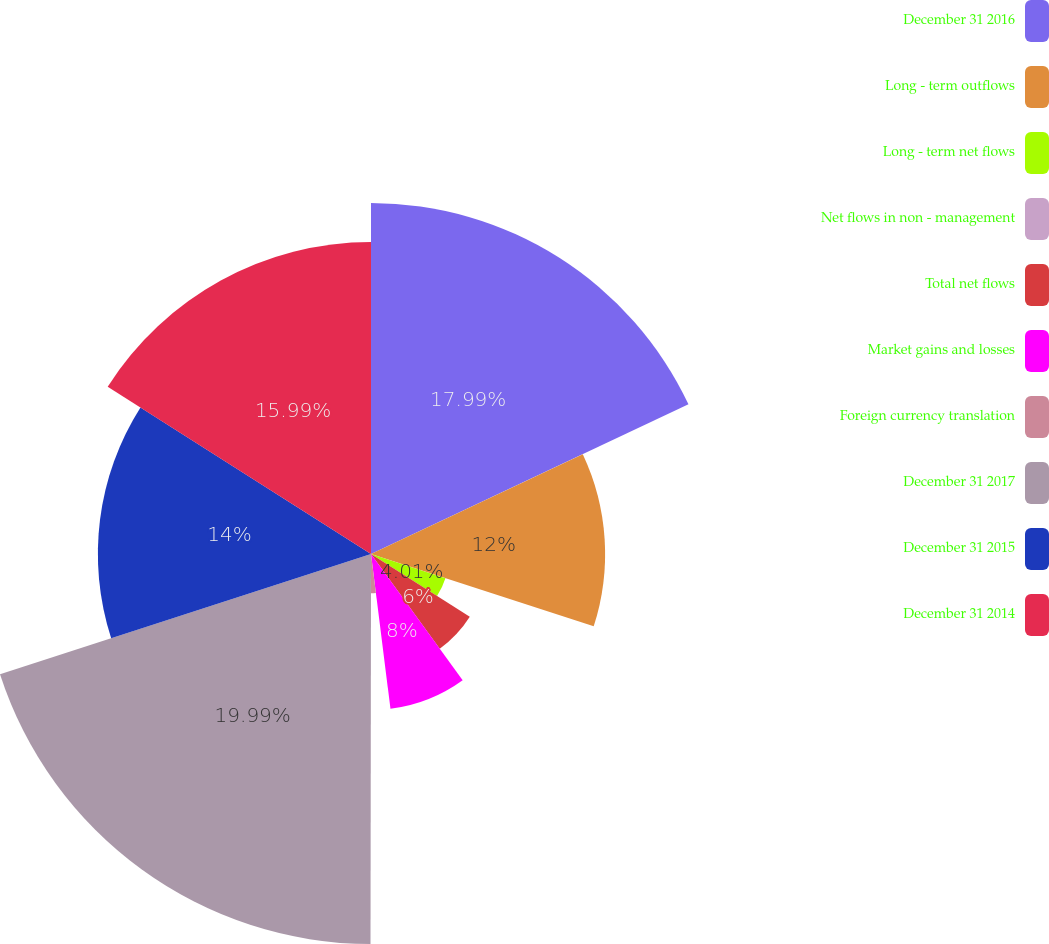Convert chart to OTSL. <chart><loc_0><loc_0><loc_500><loc_500><pie_chart><fcel>December 31 2016<fcel>Long - term outflows<fcel>Long - term net flows<fcel>Net flows in non - management<fcel>Total net flows<fcel>Market gains and losses<fcel>Foreign currency translation<fcel>December 31 2017<fcel>December 31 2015<fcel>December 31 2014<nl><fcel>17.99%<fcel>12.0%<fcel>4.01%<fcel>0.01%<fcel>6.0%<fcel>8.0%<fcel>2.01%<fcel>19.99%<fcel>14.0%<fcel>15.99%<nl></chart> 